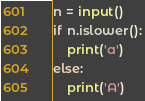<code> <loc_0><loc_0><loc_500><loc_500><_Python_>n = input()
if n.islower():
    print('a')
else:
    print('A')</code> 